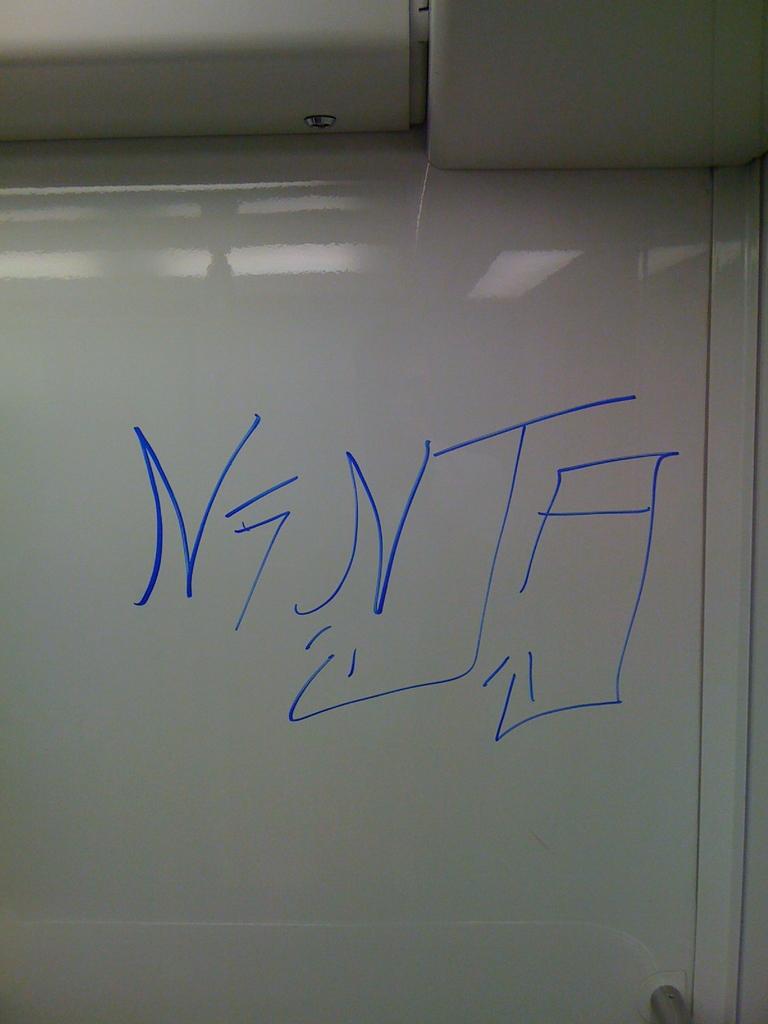What word did they write on the white board?
Your answer should be very brief. Ninja. 